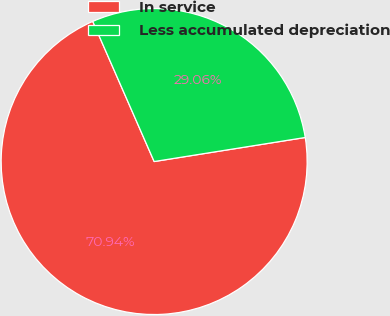Convert chart. <chart><loc_0><loc_0><loc_500><loc_500><pie_chart><fcel>In service<fcel>Less accumulated depreciation<nl><fcel>70.94%<fcel>29.06%<nl></chart> 